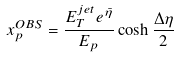Convert formula to latex. <formula><loc_0><loc_0><loc_500><loc_500>x _ { p } ^ { O B S } = \frac { E _ { T } ^ { j e t } e ^ { \bar { \eta } } } { E _ { p } } \cosh \frac { \Delta \eta } { 2 }</formula> 